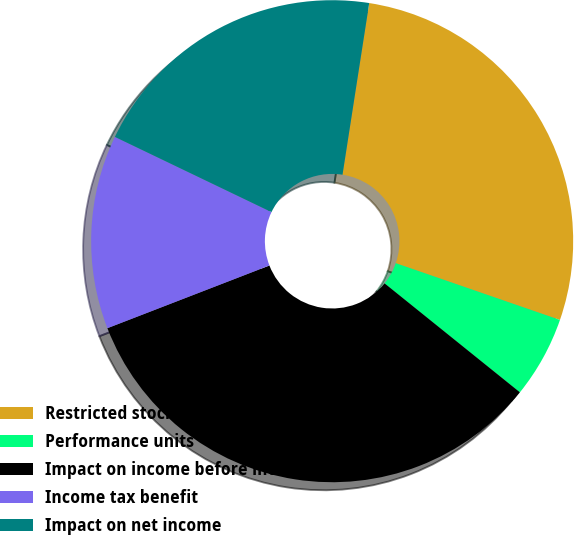<chart> <loc_0><loc_0><loc_500><loc_500><pie_chart><fcel>Restricted stock<fcel>Performance units<fcel>Impact on income before income<fcel>Income tax benefit<fcel>Impact on net income<nl><fcel>27.84%<fcel>5.49%<fcel>33.33%<fcel>13.0%<fcel>20.33%<nl></chart> 